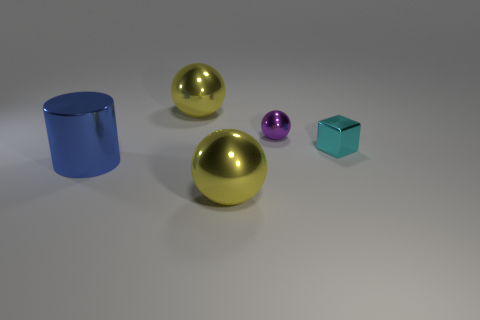Does the shiny cylinder have the same size as the purple object behind the small cyan shiny thing?
Your response must be concise. No. Is there any other thing that is the same material as the cyan object?
Your response must be concise. Yes. There is a yellow metallic ball that is in front of the big blue object; is it the same size as the yellow metallic thing behind the blue metallic cylinder?
Ensure brevity in your answer.  Yes. What number of big things are metallic balls or cyan rubber cubes?
Ensure brevity in your answer.  2. How many things are both to the right of the cylinder and on the left side of the tiny shiny ball?
Keep it short and to the point. 2. Is the purple sphere made of the same material as the sphere in front of the small purple ball?
Your response must be concise. Yes. How many cyan objects are cubes or shiny things?
Provide a short and direct response. 1. Are there any other red shiny cylinders of the same size as the metallic cylinder?
Your answer should be very brief. No. What is the material of the blue cylinder on the left side of the large yellow ball that is in front of the large object that is behind the big blue metal cylinder?
Give a very brief answer. Metal. Are there an equal number of tiny cyan things that are on the left side of the tiny purple metallic thing and small purple shiny things?
Provide a succinct answer. No. 